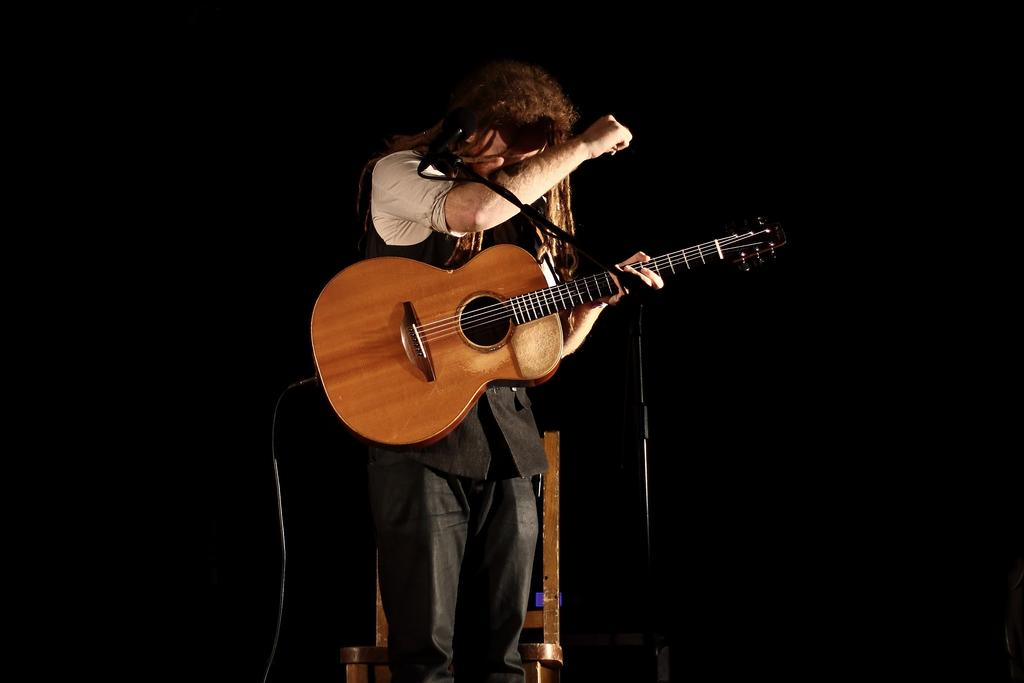Who is the main subject in the image? There is a man in the image. What is the man wearing? The man is wearing a black dress. What object is the man holding? The man is holding a guitar. What is the purpose of the microphone in front of the man? The microphone is likely used for amplifying the man's voice while he plays the guitar. What is the color of the background in the image? The background of the image is black. Can you tell me how many nuts are on the man's head in the image? There are no nuts present on the man's head in the image. What type of heart-shaped object can be seen in the image? There is no heart-shaped object present in the image. 